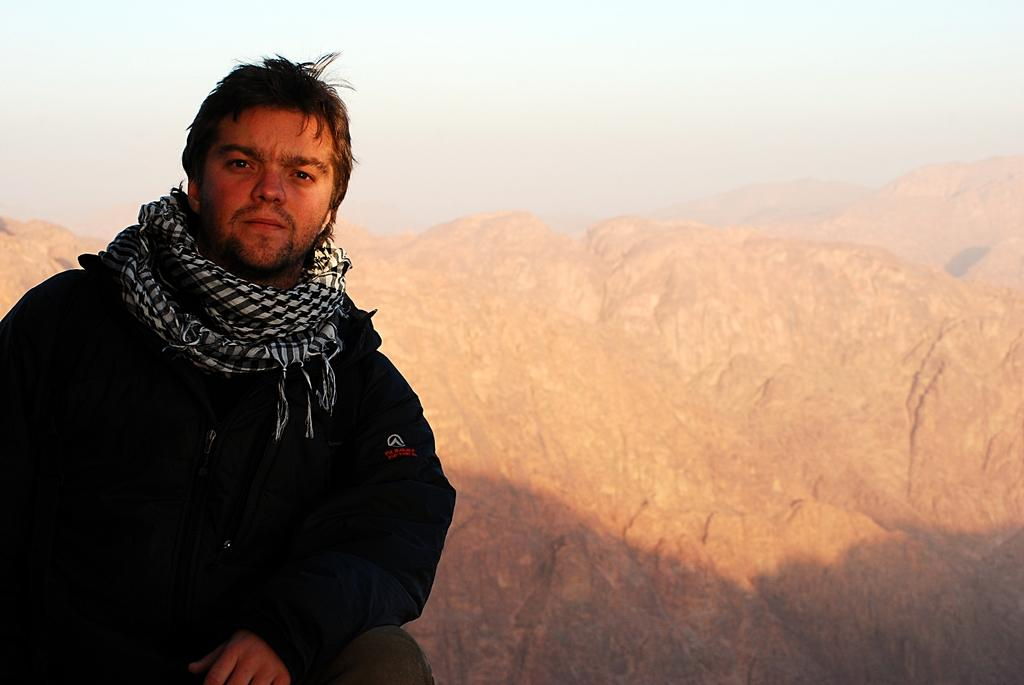Who or what is on the left side of the image? There is a person on the left side of the image. What can be observed about the person's clothing? The person is wearing a black coat and a stole. What is visible in the background of the image? There are mountains in the background of the image. What type of song is being sung by the person in the image? There is no indication in the image that the person is singing a song, so it cannot be determined from the picture. 